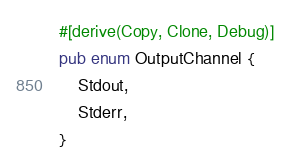Convert code to text. <code><loc_0><loc_0><loc_500><loc_500><_Rust_>#[derive(Copy, Clone, Debug)]
pub enum OutputChannel {
    Stdout,
    Stderr,
}
</code> 